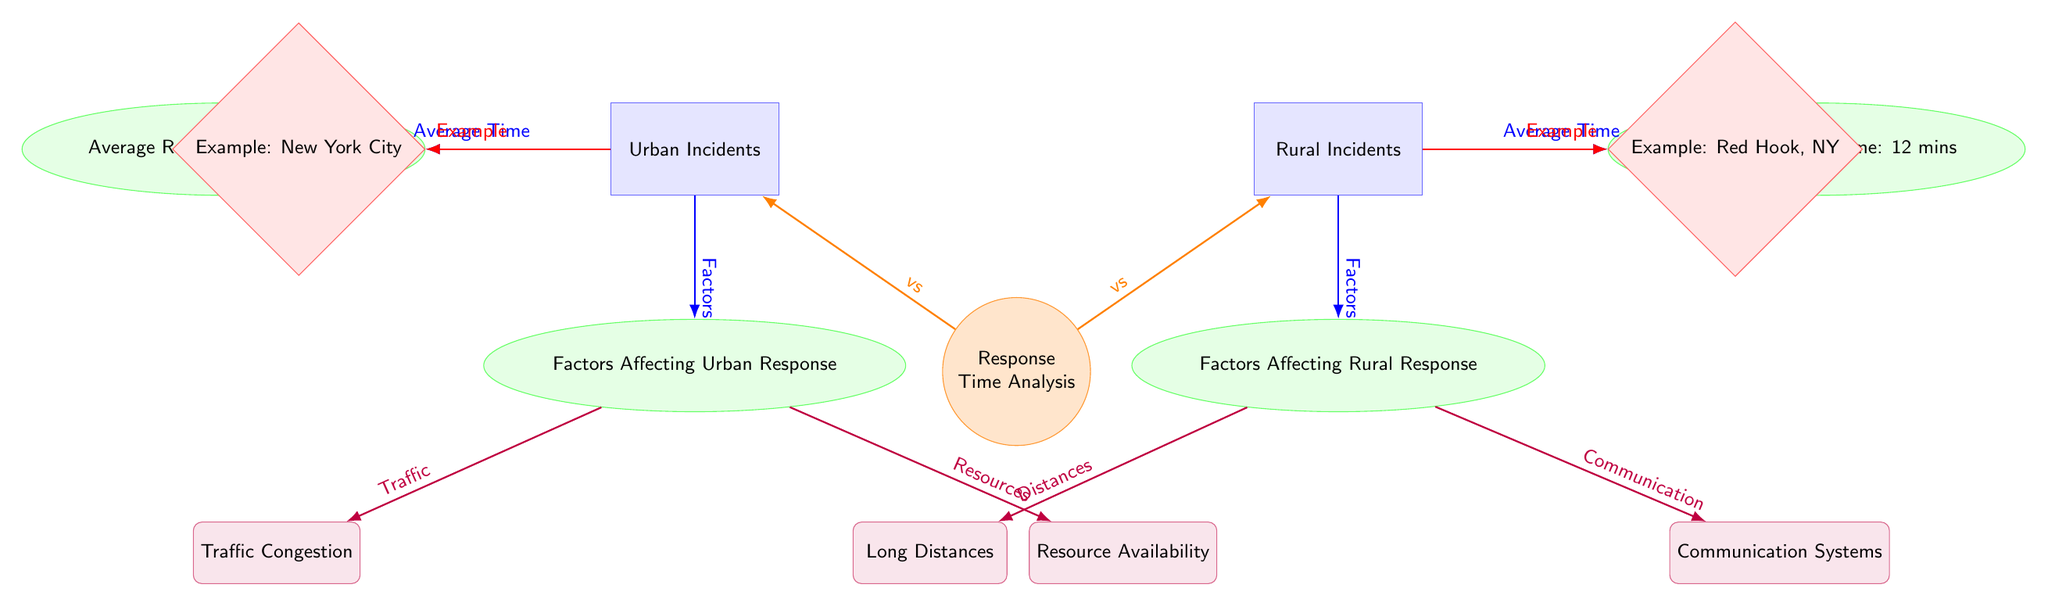What is the average response time for urban incidents? The diagram shows that the average response time for urban incidents is represented in the subcategory connected to the urban category. It specifies that the average response time is 6 minutes.
Answer: 6 mins What is the average response time for rural incidents? Similarly, the average response time for rural incidents is found in the subcategory linked to the rural category. It indicates that the average response time is 12 minutes.
Answer: 12 mins What are the factors affecting urban response time? The diagram indicates "Factors Affecting Urban Response" from the urban category. The two specific factors listed are Traffic Congestion and Resource Availability.
Answer: Traffic Congestion, Resource Availability What are the factors affecting rural response time? The factors influencing rural response time are found under "Factors Affecting Rural Response" from the rural category. The two specific factors mentioned are Long Distances and Communication Systems.
Answer: Long Distances, Communication Systems Which incident has a shorter average response time? By comparing the average response times listed under the urban and rural categories, urban incidents have a shorter response time of 6 minutes compared to the 12 minutes for rural incidents.
Answer: Urban incidents What is the relationship between urban and rural incidents regarding average response times? The diagram illustrates a comparative relationship between urban and rural incidents. It highlights that urban incidents have a significantly shorter average response time (6 mins) than rural incidents (12 mins), showing the contrast.
Answer: Urban incidents are faster Which example is given for urban incidents in the diagram? The diagram specifies an example of an urban incident as New York City, which is connected to the urban category.
Answer: New York City Which example is given for rural incidents in the diagram? For rural incidents, the diagram provides the example of Red Hook, NY, which is associated with the rural category.
Answer: Red Hook, NY What can be inferred about the challenges urban fire brigades face? The diagram identifies specific factors affecting urban response time, namely Traffic Congestion and Resource Availability, indicating challenges faced by urban fire brigades.
Answer: Traffic Congestion, Resource Availability How do communication systems affect rural response times? The diagram categorizes Communication Systems as a factor affecting rural response times, suggesting that poor communication can delay responses, especially over long distances in rural areas.
Answer: Communication Systems 